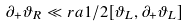<formula> <loc_0><loc_0><loc_500><loc_500>\partial _ { + } \vartheta _ { R } \ll r a 1 / 2 [ \vartheta _ { L } , \partial _ { + } \vartheta _ { L } ]</formula> 